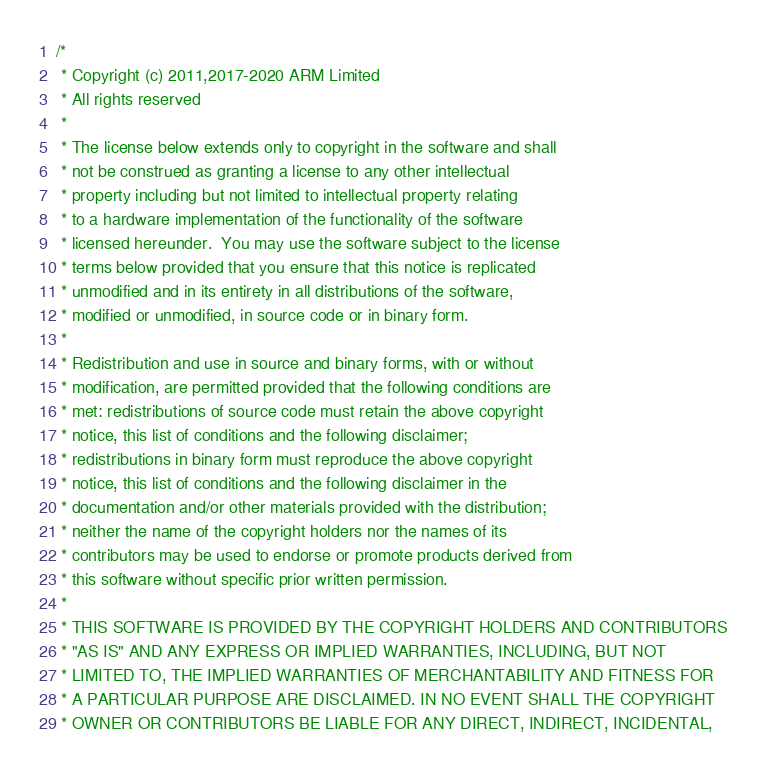Convert code to text. <code><loc_0><loc_0><loc_500><loc_500><_C++_>/*
 * Copyright (c) 2011,2017-2020 ARM Limited
 * All rights reserved
 *
 * The license below extends only to copyright in the software and shall
 * not be construed as granting a license to any other intellectual
 * property including but not limited to intellectual property relating
 * to a hardware implementation of the functionality of the software
 * licensed hereunder.  You may use the software subject to the license
 * terms below provided that you ensure that this notice is replicated
 * unmodified and in its entirety in all distributions of the software,
 * modified or unmodified, in source code or in binary form.
 *
 * Redistribution and use in source and binary forms, with or without
 * modification, are permitted provided that the following conditions are
 * met: redistributions of source code must retain the above copyright
 * notice, this list of conditions and the following disclaimer;
 * redistributions in binary form must reproduce the above copyright
 * notice, this list of conditions and the following disclaimer in the
 * documentation and/or other materials provided with the distribution;
 * neither the name of the copyright holders nor the names of its
 * contributors may be used to endorse or promote products derived from
 * this software without specific prior written permission.
 *
 * THIS SOFTWARE IS PROVIDED BY THE COPYRIGHT HOLDERS AND CONTRIBUTORS
 * "AS IS" AND ANY EXPRESS OR IMPLIED WARRANTIES, INCLUDING, BUT NOT
 * LIMITED TO, THE IMPLIED WARRANTIES OF MERCHANTABILITY AND FITNESS FOR
 * A PARTICULAR PURPOSE ARE DISCLAIMED. IN NO EVENT SHALL THE COPYRIGHT
 * OWNER OR CONTRIBUTORS BE LIABLE FOR ANY DIRECT, INDIRECT, INCIDENTAL,</code> 